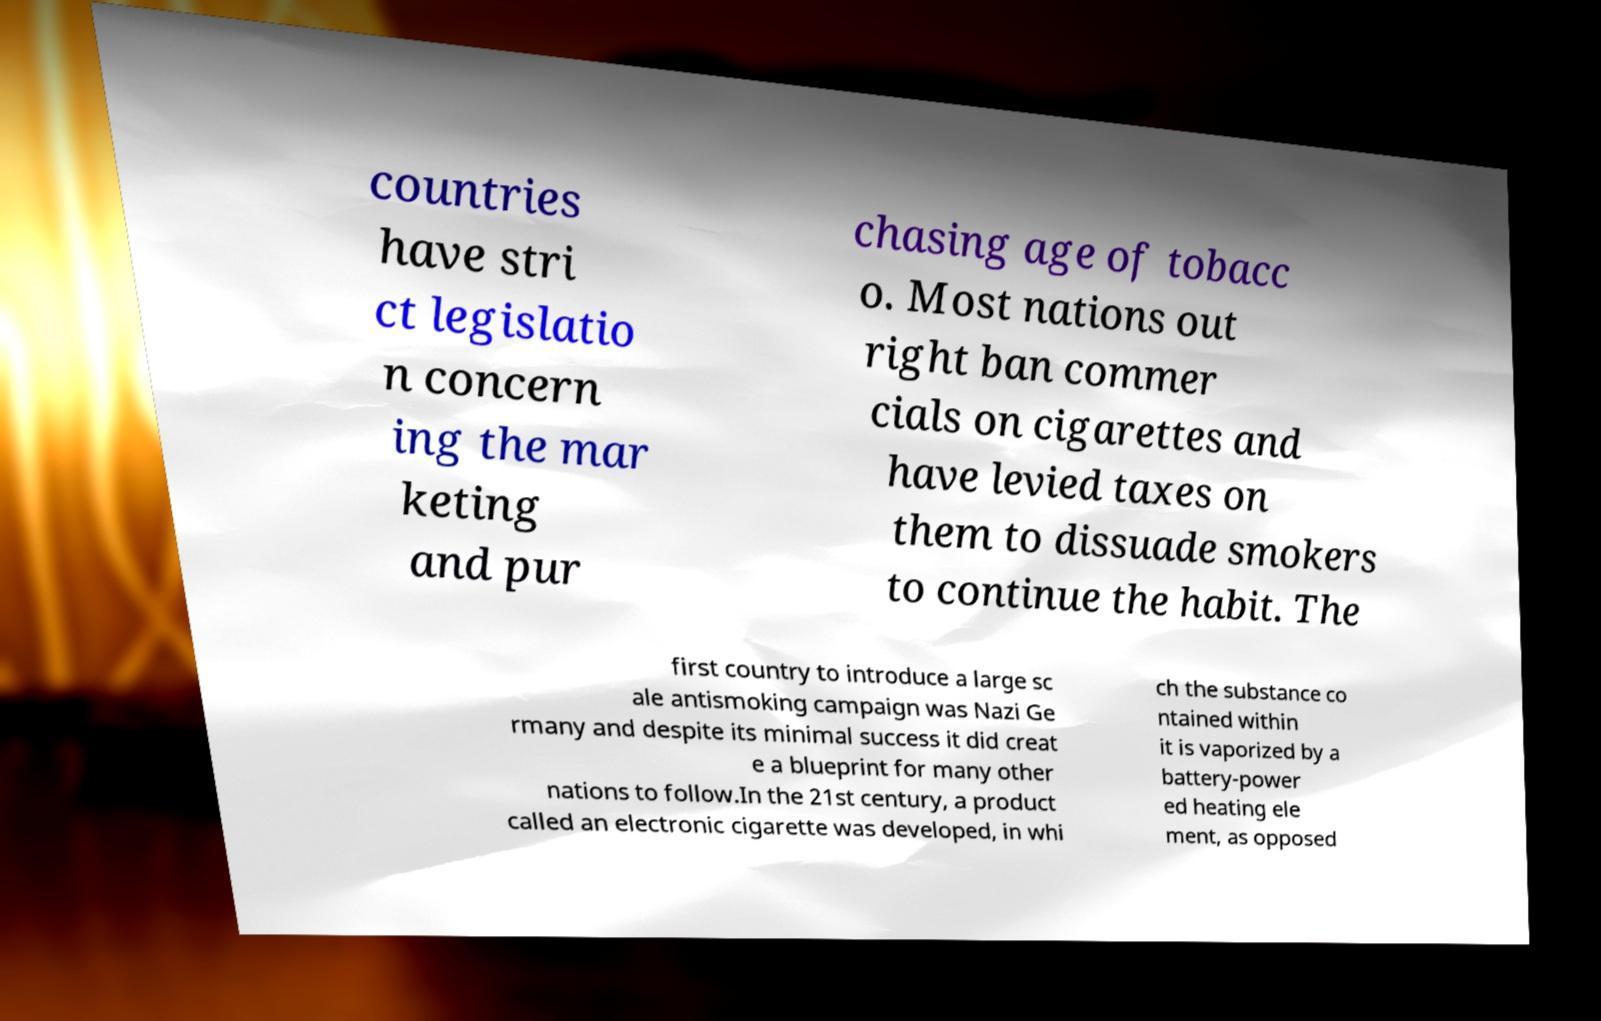Please read and relay the text visible in this image. What does it say? countries have stri ct legislatio n concern ing the mar keting and pur chasing age of tobacc o. Most nations out right ban commer cials on cigarettes and have levied taxes on them to dissuade smokers to continue the habit. The first country to introduce a large sc ale antismoking campaign was Nazi Ge rmany and despite its minimal success it did creat e a blueprint for many other nations to follow.In the 21st century, a product called an electronic cigarette was developed, in whi ch the substance co ntained within it is vaporized by a battery-power ed heating ele ment, as opposed 